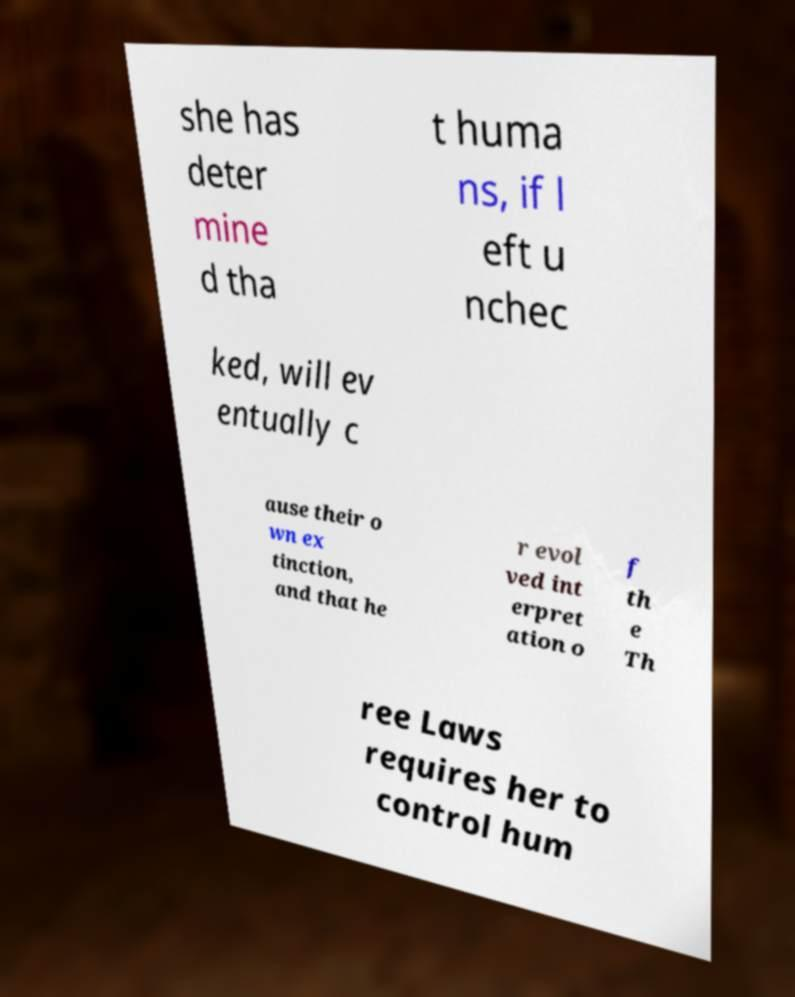There's text embedded in this image that I need extracted. Can you transcribe it verbatim? she has deter mine d tha t huma ns, if l eft u nchec ked, will ev entually c ause their o wn ex tinction, and that he r evol ved int erpret ation o f th e Th ree Laws requires her to control hum 